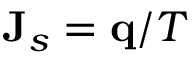<formula> <loc_0><loc_0><loc_500><loc_500>\mathbf J _ { s } = \mathbf q / T</formula> 